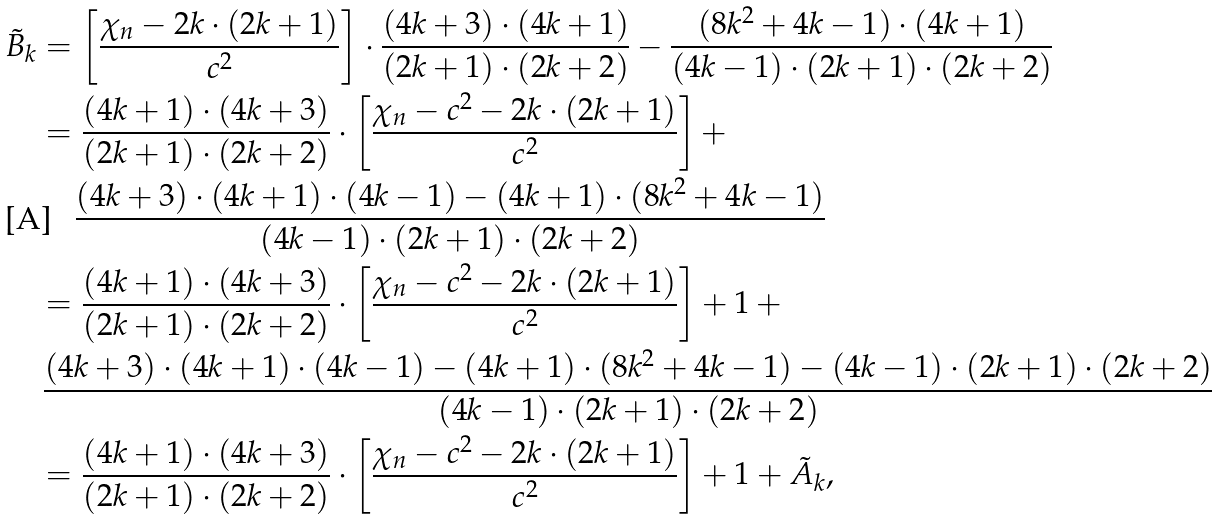<formula> <loc_0><loc_0><loc_500><loc_500>\tilde { B } _ { k } & = \left [ \frac { \chi _ { n } - 2 k \cdot ( 2 k + 1 ) } { c ^ { 2 } } \right ] \cdot \frac { ( 4 k + 3 ) \cdot ( 4 k + 1 ) } { ( 2 k + 1 ) \cdot ( 2 k + 2 ) } - \frac { ( 8 k ^ { 2 } + 4 k - 1 ) \cdot ( 4 k + 1 ) } { ( 4 k - 1 ) \cdot ( 2 k + 1 ) \cdot ( 2 k + 2 ) } \\ & = \frac { ( 4 k + 1 ) \cdot ( 4 k + 3 ) } { ( 2 k + 1 ) \cdot ( 2 k + 2 ) } \cdot \left [ \frac { \chi _ { n } - c ^ { 2 } - 2 k \cdot ( 2 k + 1 ) } { c ^ { 2 } } \right ] + \\ & \quad \, \frac { ( 4 k + 3 ) \cdot ( 4 k + 1 ) \cdot ( 4 k - 1 ) - ( 4 k + 1 ) \cdot ( 8 k ^ { 2 } + 4 k - 1 ) } { ( 4 k - 1 ) \cdot ( 2 k + 1 ) \cdot ( 2 k + 2 ) } \\ & = \frac { ( 4 k + 1 ) \cdot ( 4 k + 3 ) } { ( 2 k + 1 ) \cdot ( 2 k + 2 ) } \cdot \left [ \frac { \chi _ { n } - c ^ { 2 } - 2 k \cdot ( 2 k + 1 ) } { c ^ { 2 } } \right ] + 1 \, + \\ & \, \frac { ( 4 k + 3 ) \cdot ( 4 k + 1 ) \cdot ( 4 k - 1 ) - ( 4 k + 1 ) \cdot ( 8 k ^ { 2 } + 4 k - 1 ) - ( 4 k - 1 ) \cdot ( 2 k + 1 ) \cdot ( 2 k + 2 ) } { ( 4 k - 1 ) \cdot ( 2 k + 1 ) \cdot ( 2 k + 2 ) } \\ & = \frac { ( 4 k + 1 ) \cdot ( 4 k + 3 ) } { ( 2 k + 1 ) \cdot ( 2 k + 2 ) } \cdot \left [ \frac { \chi _ { n } - c ^ { 2 } - 2 k \cdot ( 2 k + 1 ) } { c ^ { 2 } } \right ] + 1 + \tilde { A } _ { k } ,</formula> 